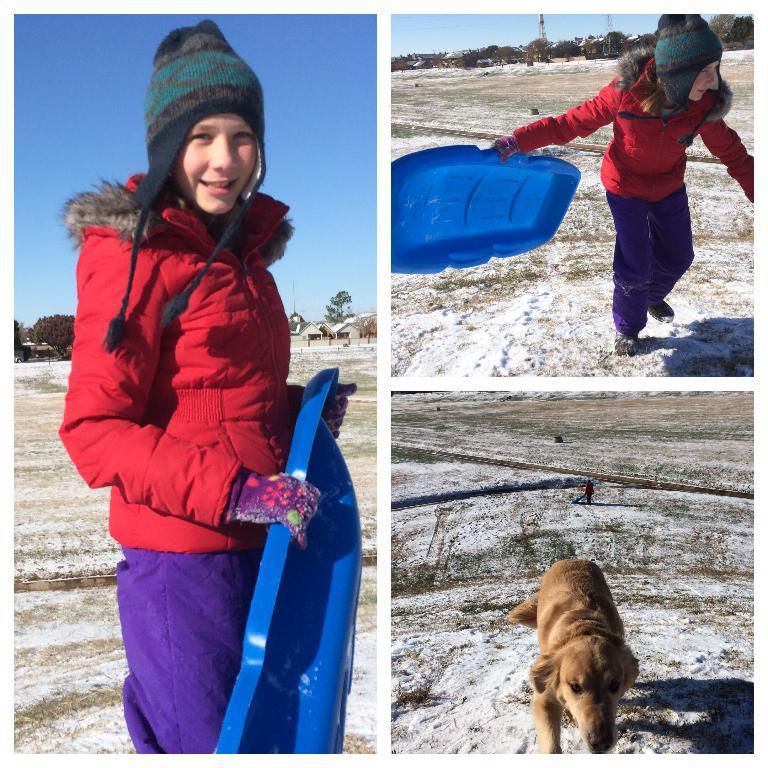Describe this image in one or two sentences. In the picture we can see three images, in the first image we can see a girl standing on the surface of the ground with some snow on it and a girl is wearing a red color jacket, cap and gloves and holding something in the hand, which is blue in color and she is smiling and in the second image we can see a same girl walking and in the third image we can see a dog walking on the surface and the dog is cream in color. 